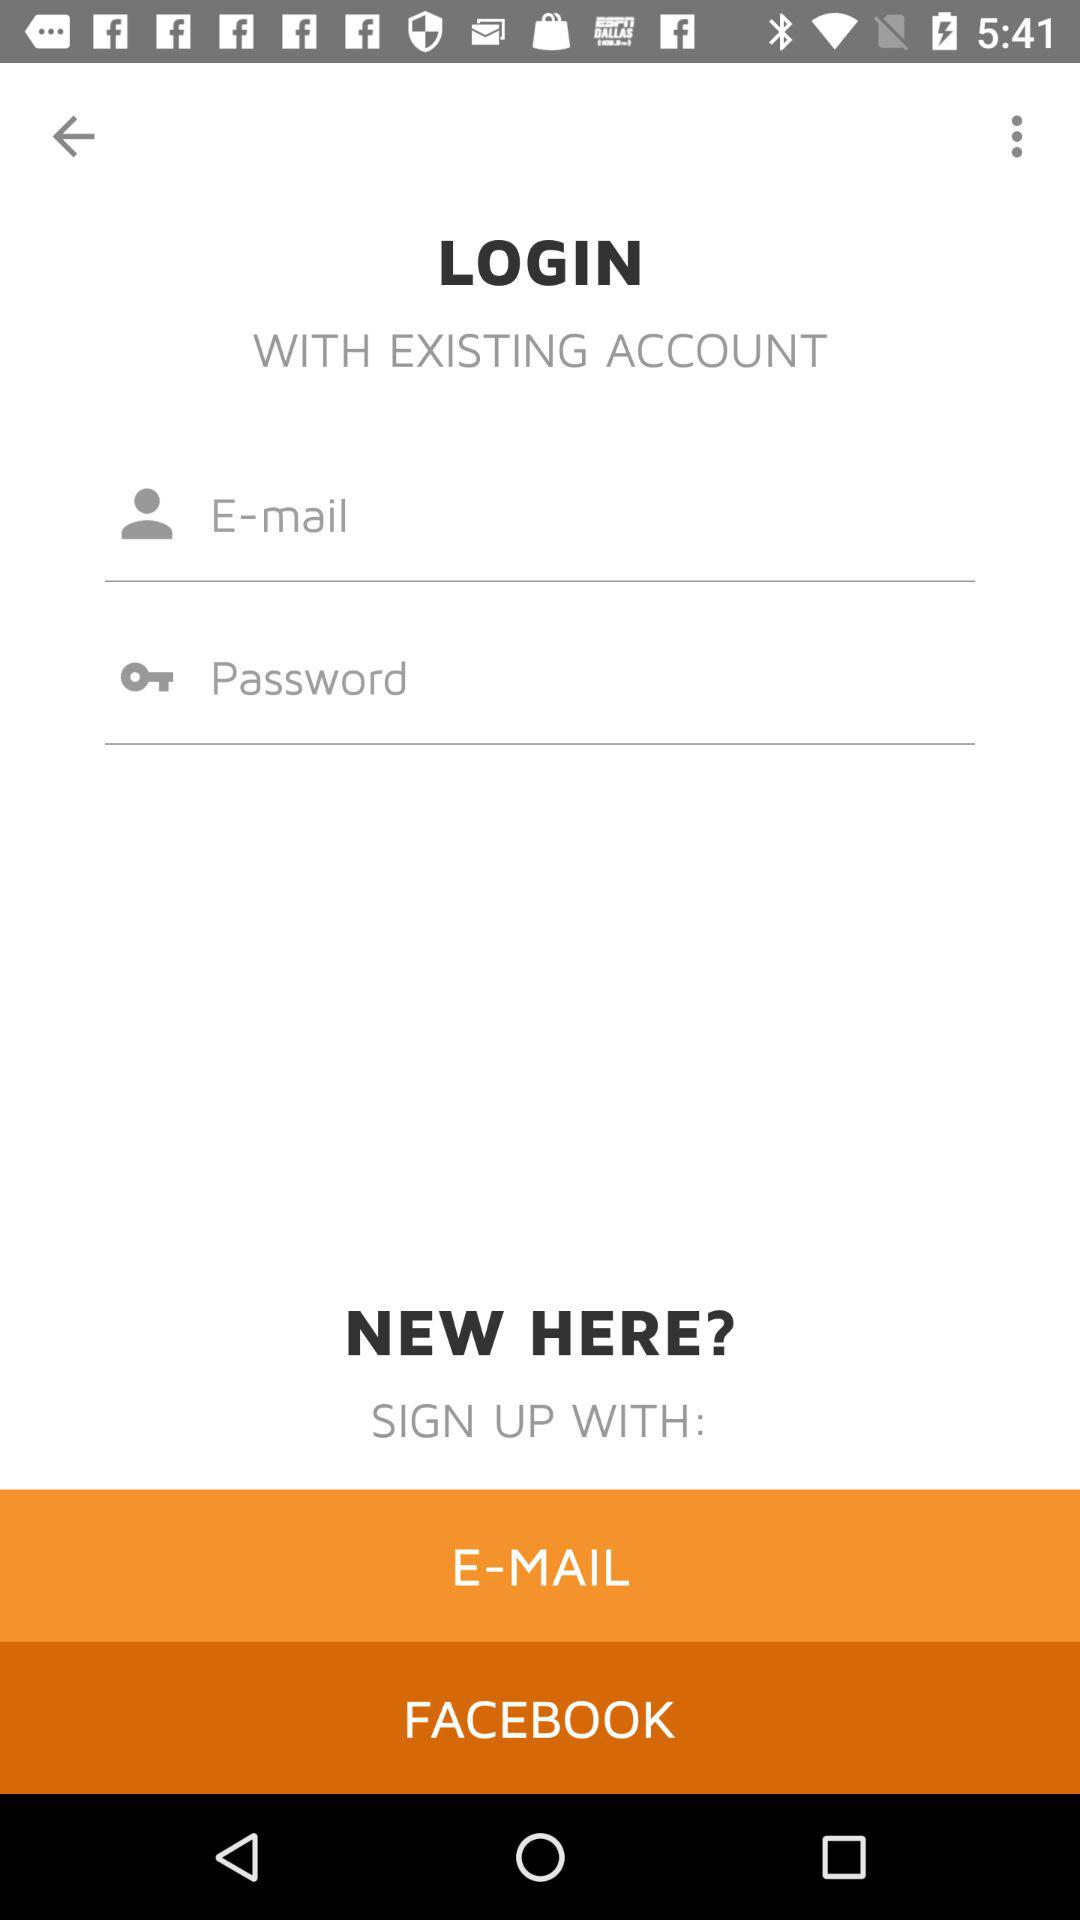What are the options to sign up? The options to sign up are "E-MAIL" and "FACEBOOK". 